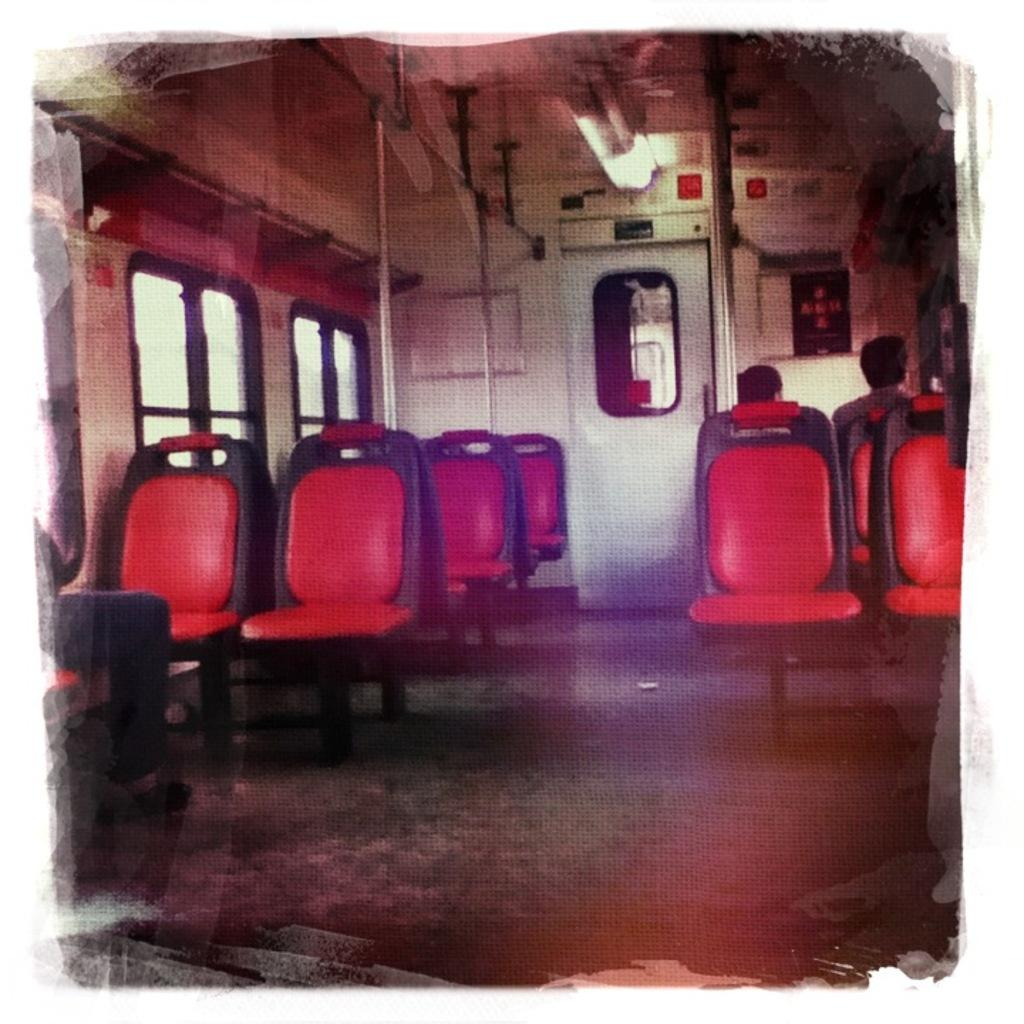What type of space is shown in the image? The image is an inside view of a vehicle. What can be seen at the top of the image? There are lights visible at the top of the image. What feature allows access to the vehicle? There is a door in the image. What type of seating is present in the vehicle? There are chairs in the image. What allows visibility of the outside while inside the vehicle? There are windows in the image. What type of shoes are visible on the floor of the vehicle in the image? There are no shoes visible in the image; it only shows the interior of the vehicle with lights, a door, chairs, and windows. 